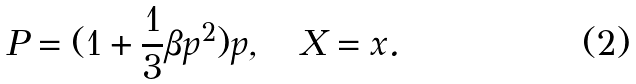Convert formula to latex. <formula><loc_0><loc_0><loc_500><loc_500>P = ( 1 + \frac { 1 } { 3 } \beta p ^ { 2 } ) p , \quad X = x .</formula> 